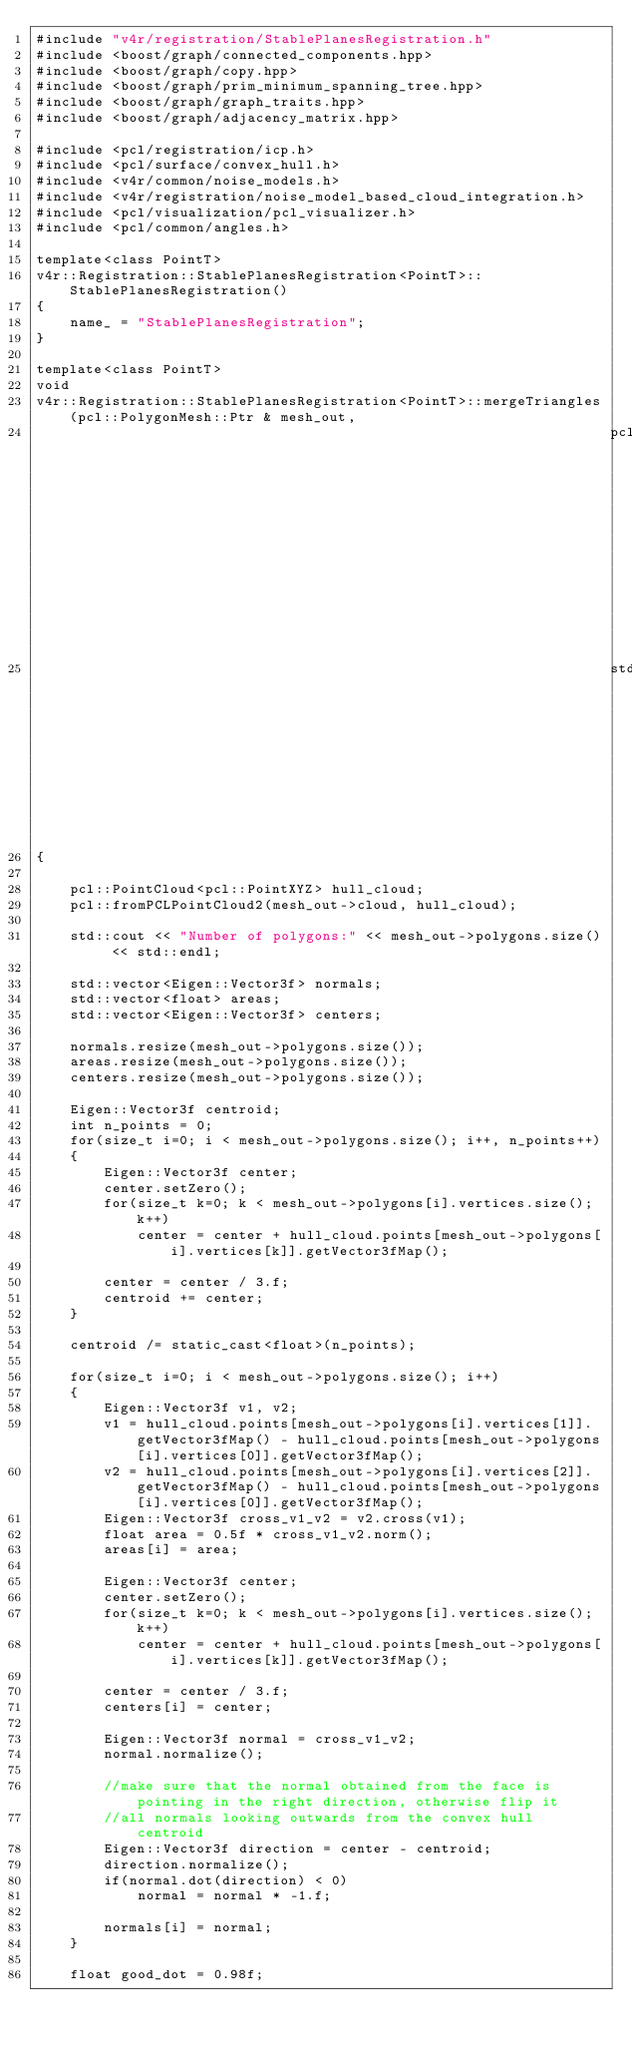<code> <loc_0><loc_0><loc_500><loc_500><_C++_>#include "v4r/registration/StablePlanesRegistration.h"
#include <boost/graph/connected_components.hpp>
#include <boost/graph/copy.hpp>
#include <boost/graph/prim_minimum_spanning_tree.hpp>
#include <boost/graph/graph_traits.hpp>
#include <boost/graph/adjacency_matrix.hpp>

#include <pcl/registration/icp.h>
#include <pcl/surface/convex_hull.h>
#include <v4r/common/noise_models.h>
#include <v4r/registration/noise_model_based_cloud_integration.h>
#include <pcl/visualization/pcl_visualizer.h>
#include <pcl/common/angles.h>

template<class PointT>
v4r::Registration::StablePlanesRegistration<PointT>::StablePlanesRegistration()
{
    name_ = "StablePlanesRegistration";
}

template<class PointT>
void
v4r::Registration::StablePlanesRegistration<PointT>::mergeTriangles(pcl::PolygonMesh::Ptr & mesh_out,
                                                                    pcl::PointCloud<pcl::PointXYZRGBNormal>::Ptr & model_cloud,
                                                                    std::vector<stablePlane> & stable_planes)
{

    pcl::PointCloud<pcl::PointXYZ> hull_cloud;
    pcl::fromPCLPointCloud2(mesh_out->cloud, hull_cloud);

    std::cout << "Number of polygons:" << mesh_out->polygons.size() << std::endl;

    std::vector<Eigen::Vector3f> normals;
    std::vector<float> areas;
    std::vector<Eigen::Vector3f> centers;

    normals.resize(mesh_out->polygons.size());
    areas.resize(mesh_out->polygons.size());
    centers.resize(mesh_out->polygons.size());

    Eigen::Vector3f centroid;
    int n_points = 0;
    for(size_t i=0; i < mesh_out->polygons.size(); i++, n_points++)
    {
        Eigen::Vector3f center;
        center.setZero();
        for(size_t k=0; k < mesh_out->polygons[i].vertices.size(); k++)
            center = center + hull_cloud.points[mesh_out->polygons[i].vertices[k]].getVector3fMap();

        center = center / 3.f;
        centroid += center;
    }

    centroid /= static_cast<float>(n_points);

    for(size_t i=0; i < mesh_out->polygons.size(); i++)
    {
        Eigen::Vector3f v1, v2;
        v1 = hull_cloud.points[mesh_out->polygons[i].vertices[1]].getVector3fMap() - hull_cloud.points[mesh_out->polygons[i].vertices[0]].getVector3fMap();
        v2 = hull_cloud.points[mesh_out->polygons[i].vertices[2]].getVector3fMap() - hull_cloud.points[mesh_out->polygons[i].vertices[0]].getVector3fMap();
        Eigen::Vector3f cross_v1_v2 = v2.cross(v1);
        float area = 0.5f * cross_v1_v2.norm();
        areas[i] = area;

        Eigen::Vector3f center;
        center.setZero();
        for(size_t k=0; k < mesh_out->polygons[i].vertices.size(); k++)
            center = center + hull_cloud.points[mesh_out->polygons[i].vertices[k]].getVector3fMap();

        center = center / 3.f;
        centers[i] = center;

        Eigen::Vector3f normal = cross_v1_v2;
        normal.normalize();

        //make sure that the normal obtained from the face is pointing in the right direction, otherwise flip it
        //all normals looking outwards from the convex hull centroid
        Eigen::Vector3f direction = center - centroid;
        direction.normalize();
        if(normal.dot(direction) < 0)
            normal = normal * -1.f;

        normals[i] = normal;
    }

    float good_dot = 0.98f;</code> 